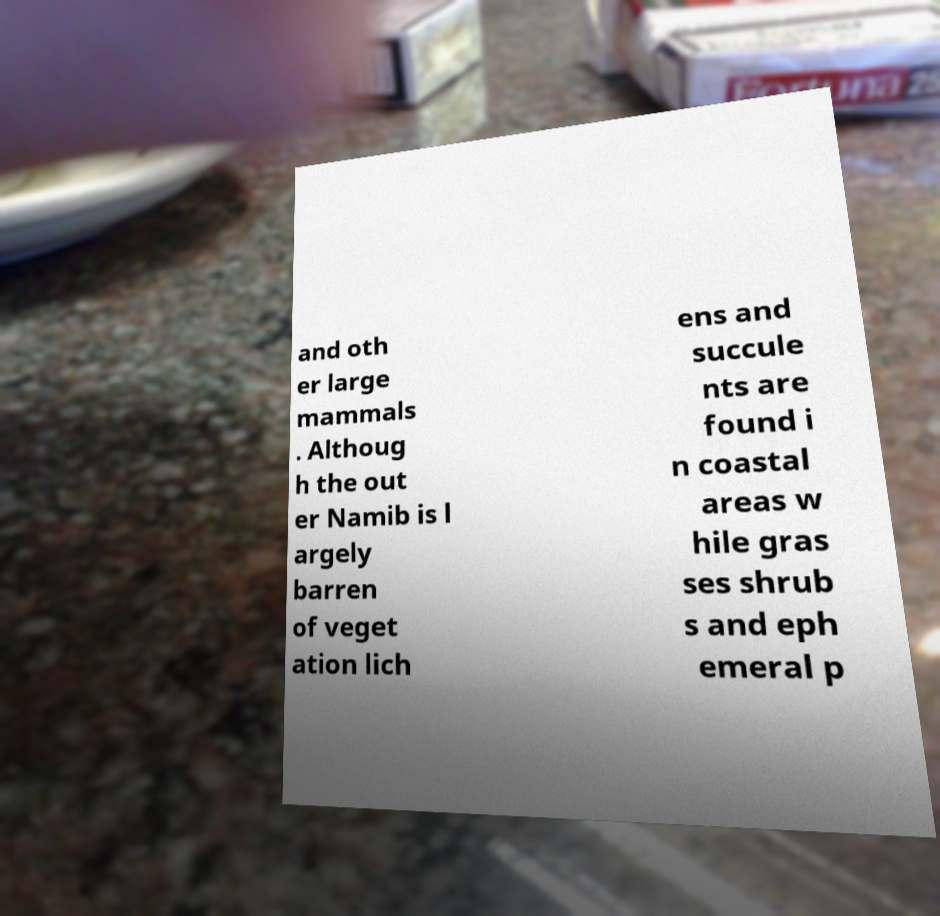Please read and relay the text visible in this image. What does it say? and oth er large mammals . Althoug h the out er Namib is l argely barren of veget ation lich ens and succule nts are found i n coastal areas w hile gras ses shrub s and eph emeral p 